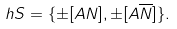<formula> <loc_0><loc_0><loc_500><loc_500>\ h S = \{ \pm [ A N ] , \pm [ A \overline { N } ] \} .</formula> 